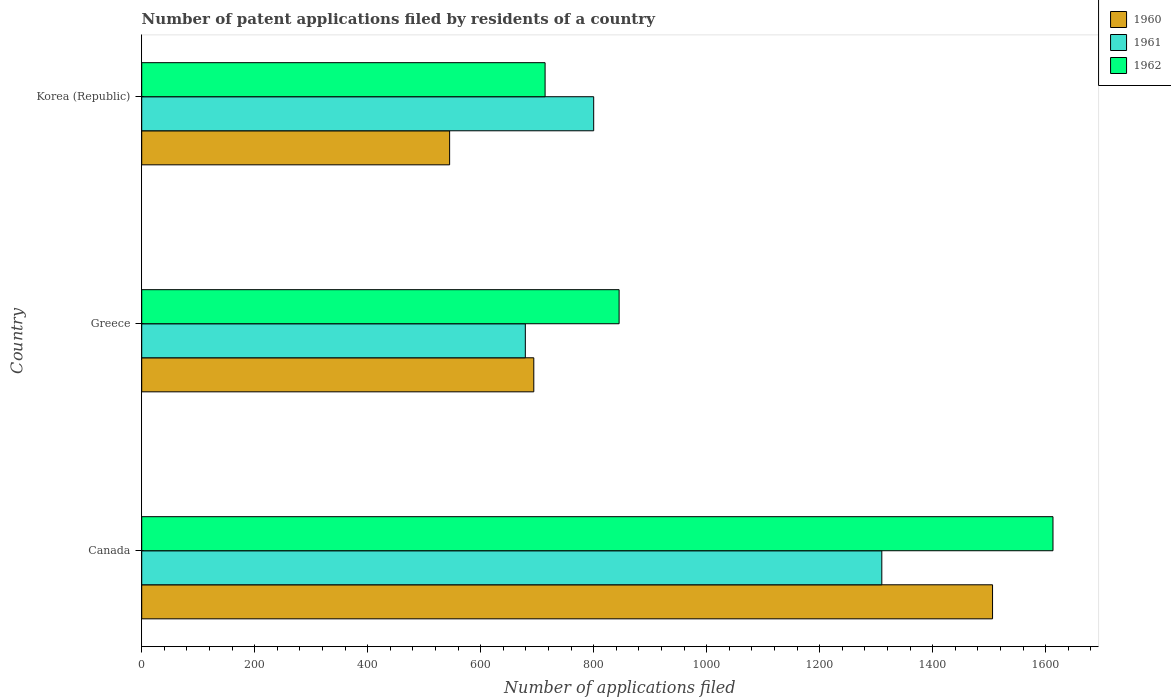Are the number of bars on each tick of the Y-axis equal?
Offer a very short reply. Yes. How many bars are there on the 3rd tick from the bottom?
Provide a short and direct response. 3. What is the number of applications filed in 1960 in Korea (Republic)?
Make the answer very short. 545. Across all countries, what is the maximum number of applications filed in 1962?
Offer a very short reply. 1613. Across all countries, what is the minimum number of applications filed in 1961?
Ensure brevity in your answer.  679. In which country was the number of applications filed in 1960 maximum?
Your answer should be compact. Canada. What is the total number of applications filed in 1960 in the graph?
Your answer should be compact. 2745. What is the difference between the number of applications filed in 1961 in Canada and that in Korea (Republic)?
Make the answer very short. 510. What is the difference between the number of applications filed in 1962 in Greece and the number of applications filed in 1960 in Korea (Republic)?
Offer a very short reply. 300. What is the average number of applications filed in 1962 per country?
Your response must be concise. 1057.33. What is the difference between the number of applications filed in 1961 and number of applications filed in 1962 in Canada?
Give a very brief answer. -303. What is the ratio of the number of applications filed in 1960 in Greece to that in Korea (Republic)?
Offer a terse response. 1.27. Is the number of applications filed in 1961 in Canada less than that in Greece?
Ensure brevity in your answer.  No. Is the difference between the number of applications filed in 1961 in Canada and Greece greater than the difference between the number of applications filed in 1962 in Canada and Greece?
Offer a terse response. No. What is the difference between the highest and the second highest number of applications filed in 1962?
Offer a very short reply. 768. What is the difference between the highest and the lowest number of applications filed in 1960?
Provide a short and direct response. 961. Is the sum of the number of applications filed in 1961 in Canada and Korea (Republic) greater than the maximum number of applications filed in 1962 across all countries?
Offer a very short reply. Yes. What does the 3rd bar from the bottom in Korea (Republic) represents?
Your answer should be compact. 1962. Is it the case that in every country, the sum of the number of applications filed in 1960 and number of applications filed in 1962 is greater than the number of applications filed in 1961?
Offer a terse response. Yes. Are all the bars in the graph horizontal?
Offer a terse response. Yes. What is the difference between two consecutive major ticks on the X-axis?
Ensure brevity in your answer.  200. Where does the legend appear in the graph?
Your answer should be very brief. Top right. How many legend labels are there?
Your response must be concise. 3. What is the title of the graph?
Your answer should be very brief. Number of patent applications filed by residents of a country. What is the label or title of the X-axis?
Make the answer very short. Number of applications filed. What is the label or title of the Y-axis?
Make the answer very short. Country. What is the Number of applications filed of 1960 in Canada?
Offer a very short reply. 1506. What is the Number of applications filed in 1961 in Canada?
Your response must be concise. 1310. What is the Number of applications filed in 1962 in Canada?
Your response must be concise. 1613. What is the Number of applications filed in 1960 in Greece?
Give a very brief answer. 694. What is the Number of applications filed of 1961 in Greece?
Your answer should be compact. 679. What is the Number of applications filed of 1962 in Greece?
Your answer should be very brief. 845. What is the Number of applications filed of 1960 in Korea (Republic)?
Provide a succinct answer. 545. What is the Number of applications filed in 1961 in Korea (Republic)?
Provide a short and direct response. 800. What is the Number of applications filed of 1962 in Korea (Republic)?
Your response must be concise. 714. Across all countries, what is the maximum Number of applications filed of 1960?
Make the answer very short. 1506. Across all countries, what is the maximum Number of applications filed of 1961?
Your answer should be very brief. 1310. Across all countries, what is the maximum Number of applications filed in 1962?
Offer a terse response. 1613. Across all countries, what is the minimum Number of applications filed in 1960?
Your answer should be very brief. 545. Across all countries, what is the minimum Number of applications filed of 1961?
Your response must be concise. 679. Across all countries, what is the minimum Number of applications filed of 1962?
Keep it short and to the point. 714. What is the total Number of applications filed of 1960 in the graph?
Your response must be concise. 2745. What is the total Number of applications filed in 1961 in the graph?
Offer a terse response. 2789. What is the total Number of applications filed of 1962 in the graph?
Give a very brief answer. 3172. What is the difference between the Number of applications filed of 1960 in Canada and that in Greece?
Ensure brevity in your answer.  812. What is the difference between the Number of applications filed in 1961 in Canada and that in Greece?
Ensure brevity in your answer.  631. What is the difference between the Number of applications filed in 1962 in Canada and that in Greece?
Make the answer very short. 768. What is the difference between the Number of applications filed in 1960 in Canada and that in Korea (Republic)?
Offer a terse response. 961. What is the difference between the Number of applications filed of 1961 in Canada and that in Korea (Republic)?
Provide a succinct answer. 510. What is the difference between the Number of applications filed in 1962 in Canada and that in Korea (Republic)?
Offer a very short reply. 899. What is the difference between the Number of applications filed in 1960 in Greece and that in Korea (Republic)?
Your answer should be compact. 149. What is the difference between the Number of applications filed of 1961 in Greece and that in Korea (Republic)?
Give a very brief answer. -121. What is the difference between the Number of applications filed in 1962 in Greece and that in Korea (Republic)?
Give a very brief answer. 131. What is the difference between the Number of applications filed of 1960 in Canada and the Number of applications filed of 1961 in Greece?
Your response must be concise. 827. What is the difference between the Number of applications filed of 1960 in Canada and the Number of applications filed of 1962 in Greece?
Your answer should be compact. 661. What is the difference between the Number of applications filed of 1961 in Canada and the Number of applications filed of 1962 in Greece?
Provide a succinct answer. 465. What is the difference between the Number of applications filed of 1960 in Canada and the Number of applications filed of 1961 in Korea (Republic)?
Keep it short and to the point. 706. What is the difference between the Number of applications filed in 1960 in Canada and the Number of applications filed in 1962 in Korea (Republic)?
Give a very brief answer. 792. What is the difference between the Number of applications filed in 1961 in Canada and the Number of applications filed in 1962 in Korea (Republic)?
Your answer should be compact. 596. What is the difference between the Number of applications filed in 1960 in Greece and the Number of applications filed in 1961 in Korea (Republic)?
Provide a succinct answer. -106. What is the difference between the Number of applications filed in 1961 in Greece and the Number of applications filed in 1962 in Korea (Republic)?
Ensure brevity in your answer.  -35. What is the average Number of applications filed in 1960 per country?
Give a very brief answer. 915. What is the average Number of applications filed of 1961 per country?
Give a very brief answer. 929.67. What is the average Number of applications filed in 1962 per country?
Your answer should be compact. 1057.33. What is the difference between the Number of applications filed in 1960 and Number of applications filed in 1961 in Canada?
Your answer should be compact. 196. What is the difference between the Number of applications filed in 1960 and Number of applications filed in 1962 in Canada?
Make the answer very short. -107. What is the difference between the Number of applications filed of 1961 and Number of applications filed of 1962 in Canada?
Your answer should be very brief. -303. What is the difference between the Number of applications filed in 1960 and Number of applications filed in 1961 in Greece?
Your answer should be compact. 15. What is the difference between the Number of applications filed in 1960 and Number of applications filed in 1962 in Greece?
Your answer should be compact. -151. What is the difference between the Number of applications filed of 1961 and Number of applications filed of 1962 in Greece?
Ensure brevity in your answer.  -166. What is the difference between the Number of applications filed in 1960 and Number of applications filed in 1961 in Korea (Republic)?
Provide a succinct answer. -255. What is the difference between the Number of applications filed of 1960 and Number of applications filed of 1962 in Korea (Republic)?
Ensure brevity in your answer.  -169. What is the difference between the Number of applications filed in 1961 and Number of applications filed in 1962 in Korea (Republic)?
Make the answer very short. 86. What is the ratio of the Number of applications filed of 1960 in Canada to that in Greece?
Keep it short and to the point. 2.17. What is the ratio of the Number of applications filed in 1961 in Canada to that in Greece?
Provide a succinct answer. 1.93. What is the ratio of the Number of applications filed of 1962 in Canada to that in Greece?
Your answer should be very brief. 1.91. What is the ratio of the Number of applications filed in 1960 in Canada to that in Korea (Republic)?
Give a very brief answer. 2.76. What is the ratio of the Number of applications filed in 1961 in Canada to that in Korea (Republic)?
Give a very brief answer. 1.64. What is the ratio of the Number of applications filed in 1962 in Canada to that in Korea (Republic)?
Offer a terse response. 2.26. What is the ratio of the Number of applications filed in 1960 in Greece to that in Korea (Republic)?
Provide a succinct answer. 1.27. What is the ratio of the Number of applications filed in 1961 in Greece to that in Korea (Republic)?
Make the answer very short. 0.85. What is the ratio of the Number of applications filed in 1962 in Greece to that in Korea (Republic)?
Give a very brief answer. 1.18. What is the difference between the highest and the second highest Number of applications filed in 1960?
Keep it short and to the point. 812. What is the difference between the highest and the second highest Number of applications filed in 1961?
Keep it short and to the point. 510. What is the difference between the highest and the second highest Number of applications filed of 1962?
Give a very brief answer. 768. What is the difference between the highest and the lowest Number of applications filed of 1960?
Your answer should be compact. 961. What is the difference between the highest and the lowest Number of applications filed of 1961?
Give a very brief answer. 631. What is the difference between the highest and the lowest Number of applications filed of 1962?
Keep it short and to the point. 899. 